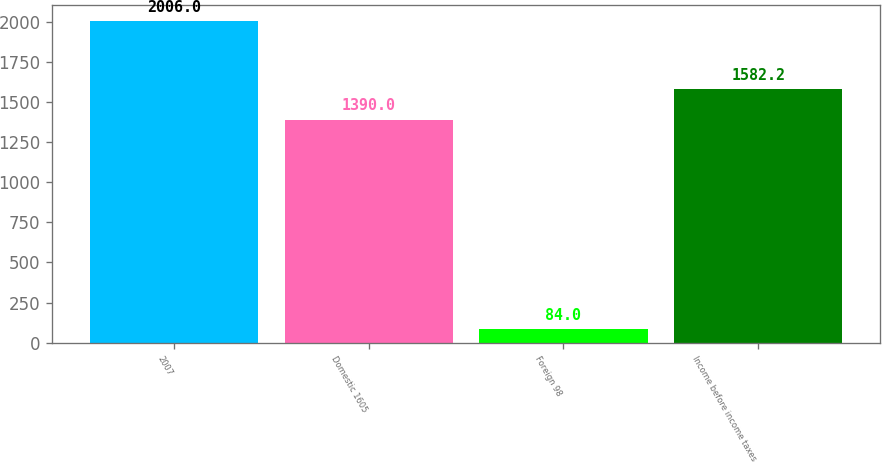Convert chart to OTSL. <chart><loc_0><loc_0><loc_500><loc_500><bar_chart><fcel>2007<fcel>Domestic 1605<fcel>Foreign 98<fcel>Income before income taxes<nl><fcel>2006<fcel>1390<fcel>84<fcel>1582.2<nl></chart> 